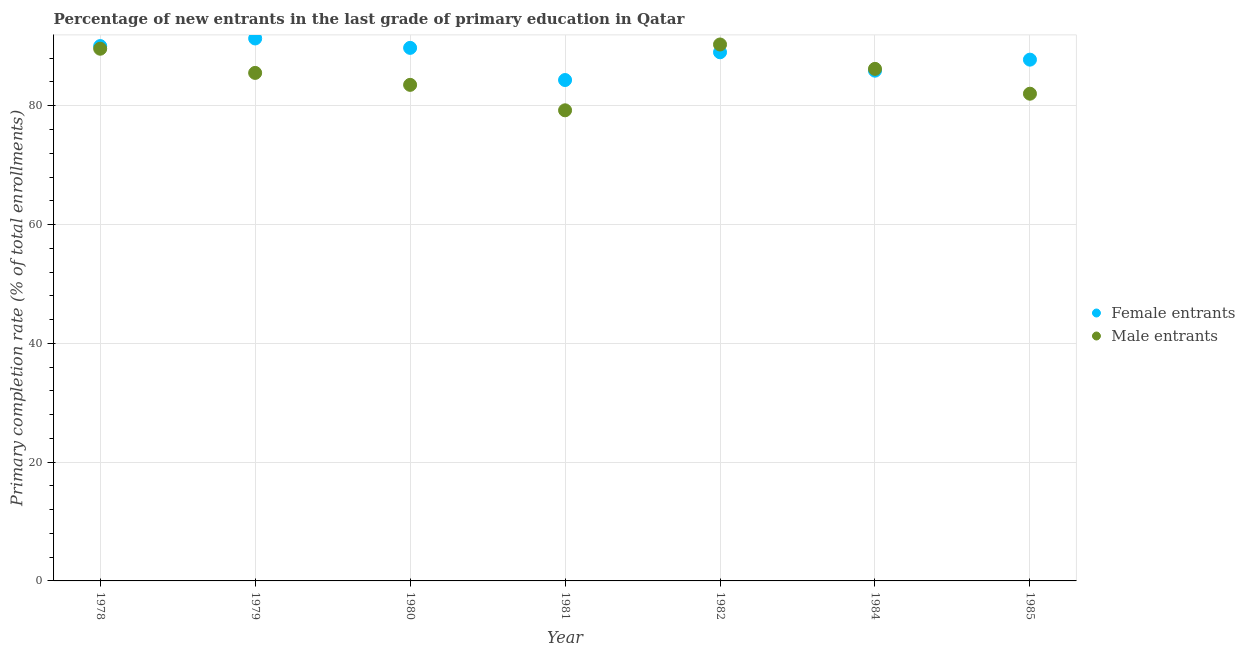How many different coloured dotlines are there?
Give a very brief answer. 2. Is the number of dotlines equal to the number of legend labels?
Offer a terse response. Yes. What is the primary completion rate of female entrants in 1982?
Make the answer very short. 89. Across all years, what is the maximum primary completion rate of male entrants?
Give a very brief answer. 90.31. Across all years, what is the minimum primary completion rate of male entrants?
Provide a succinct answer. 79.23. In which year was the primary completion rate of male entrants maximum?
Give a very brief answer. 1982. What is the total primary completion rate of male entrants in the graph?
Provide a short and direct response. 596.42. What is the difference between the primary completion rate of male entrants in 1978 and that in 1984?
Your answer should be very brief. 3.39. What is the difference between the primary completion rate of male entrants in 1982 and the primary completion rate of female entrants in 1979?
Give a very brief answer. -1.01. What is the average primary completion rate of female entrants per year?
Your answer should be very brief. 88.3. In the year 1980, what is the difference between the primary completion rate of male entrants and primary completion rate of female entrants?
Offer a terse response. -6.23. In how many years, is the primary completion rate of male entrants greater than 80 %?
Your answer should be very brief. 6. What is the ratio of the primary completion rate of male entrants in 1978 to that in 1984?
Your answer should be very brief. 1.04. Is the primary completion rate of male entrants in 1979 less than that in 1980?
Ensure brevity in your answer.  No. Is the difference between the primary completion rate of female entrants in 1981 and 1982 greater than the difference between the primary completion rate of male entrants in 1981 and 1982?
Provide a succinct answer. Yes. What is the difference between the highest and the second highest primary completion rate of female entrants?
Offer a terse response. 1.28. What is the difference between the highest and the lowest primary completion rate of male entrants?
Provide a succinct answer. 11.08. In how many years, is the primary completion rate of male entrants greater than the average primary completion rate of male entrants taken over all years?
Ensure brevity in your answer.  4. Is the sum of the primary completion rate of female entrants in 1979 and 1982 greater than the maximum primary completion rate of male entrants across all years?
Your response must be concise. Yes. Is the primary completion rate of female entrants strictly less than the primary completion rate of male entrants over the years?
Provide a succinct answer. No. How many years are there in the graph?
Make the answer very short. 7. What is the difference between two consecutive major ticks on the Y-axis?
Keep it short and to the point. 20. Are the values on the major ticks of Y-axis written in scientific E-notation?
Ensure brevity in your answer.  No. Does the graph contain any zero values?
Your answer should be very brief. No. Does the graph contain grids?
Your response must be concise. Yes. Where does the legend appear in the graph?
Give a very brief answer. Center right. What is the title of the graph?
Your answer should be very brief. Percentage of new entrants in the last grade of primary education in Qatar. What is the label or title of the Y-axis?
Make the answer very short. Primary completion rate (% of total enrollments). What is the Primary completion rate (% of total enrollments) in Female entrants in 1978?
Give a very brief answer. 90.05. What is the Primary completion rate (% of total enrollments) in Male entrants in 1978?
Offer a very short reply. 89.6. What is the Primary completion rate (% of total enrollments) of Female entrants in 1979?
Provide a succinct answer. 91.33. What is the Primary completion rate (% of total enrollments) of Male entrants in 1979?
Make the answer very short. 85.53. What is the Primary completion rate (% of total enrollments) of Female entrants in 1980?
Your answer should be compact. 89.74. What is the Primary completion rate (% of total enrollments) of Male entrants in 1980?
Keep it short and to the point. 83.52. What is the Primary completion rate (% of total enrollments) of Female entrants in 1981?
Provide a short and direct response. 84.33. What is the Primary completion rate (% of total enrollments) in Male entrants in 1981?
Make the answer very short. 79.23. What is the Primary completion rate (% of total enrollments) of Female entrants in 1982?
Offer a terse response. 89. What is the Primary completion rate (% of total enrollments) in Male entrants in 1982?
Provide a short and direct response. 90.31. What is the Primary completion rate (% of total enrollments) of Female entrants in 1984?
Provide a succinct answer. 85.9. What is the Primary completion rate (% of total enrollments) of Male entrants in 1984?
Offer a very short reply. 86.21. What is the Primary completion rate (% of total enrollments) in Female entrants in 1985?
Keep it short and to the point. 87.76. What is the Primary completion rate (% of total enrollments) in Male entrants in 1985?
Keep it short and to the point. 82.03. Across all years, what is the maximum Primary completion rate (% of total enrollments) in Female entrants?
Keep it short and to the point. 91.33. Across all years, what is the maximum Primary completion rate (% of total enrollments) in Male entrants?
Your answer should be compact. 90.31. Across all years, what is the minimum Primary completion rate (% of total enrollments) of Female entrants?
Make the answer very short. 84.33. Across all years, what is the minimum Primary completion rate (% of total enrollments) of Male entrants?
Provide a short and direct response. 79.23. What is the total Primary completion rate (% of total enrollments) of Female entrants in the graph?
Your answer should be very brief. 618.11. What is the total Primary completion rate (% of total enrollments) of Male entrants in the graph?
Give a very brief answer. 596.42. What is the difference between the Primary completion rate (% of total enrollments) of Female entrants in 1978 and that in 1979?
Your answer should be compact. -1.28. What is the difference between the Primary completion rate (% of total enrollments) of Male entrants in 1978 and that in 1979?
Ensure brevity in your answer.  4.07. What is the difference between the Primary completion rate (% of total enrollments) of Female entrants in 1978 and that in 1980?
Keep it short and to the point. 0.3. What is the difference between the Primary completion rate (% of total enrollments) in Male entrants in 1978 and that in 1980?
Give a very brief answer. 6.08. What is the difference between the Primary completion rate (% of total enrollments) of Female entrants in 1978 and that in 1981?
Your response must be concise. 5.72. What is the difference between the Primary completion rate (% of total enrollments) of Male entrants in 1978 and that in 1981?
Your response must be concise. 10.37. What is the difference between the Primary completion rate (% of total enrollments) of Female entrants in 1978 and that in 1982?
Make the answer very short. 1.04. What is the difference between the Primary completion rate (% of total enrollments) in Male entrants in 1978 and that in 1982?
Keep it short and to the point. -0.71. What is the difference between the Primary completion rate (% of total enrollments) in Female entrants in 1978 and that in 1984?
Ensure brevity in your answer.  4.14. What is the difference between the Primary completion rate (% of total enrollments) of Male entrants in 1978 and that in 1984?
Provide a succinct answer. 3.39. What is the difference between the Primary completion rate (% of total enrollments) of Female entrants in 1978 and that in 1985?
Give a very brief answer. 2.29. What is the difference between the Primary completion rate (% of total enrollments) of Male entrants in 1978 and that in 1985?
Your answer should be compact. 7.57. What is the difference between the Primary completion rate (% of total enrollments) in Female entrants in 1979 and that in 1980?
Provide a succinct answer. 1.58. What is the difference between the Primary completion rate (% of total enrollments) in Male entrants in 1979 and that in 1980?
Ensure brevity in your answer.  2.01. What is the difference between the Primary completion rate (% of total enrollments) of Female entrants in 1979 and that in 1981?
Your answer should be compact. 7. What is the difference between the Primary completion rate (% of total enrollments) of Male entrants in 1979 and that in 1981?
Offer a terse response. 6.3. What is the difference between the Primary completion rate (% of total enrollments) in Female entrants in 1979 and that in 1982?
Give a very brief answer. 2.32. What is the difference between the Primary completion rate (% of total enrollments) in Male entrants in 1979 and that in 1982?
Your answer should be very brief. -4.79. What is the difference between the Primary completion rate (% of total enrollments) in Female entrants in 1979 and that in 1984?
Provide a short and direct response. 5.42. What is the difference between the Primary completion rate (% of total enrollments) of Male entrants in 1979 and that in 1984?
Offer a terse response. -0.68. What is the difference between the Primary completion rate (% of total enrollments) in Female entrants in 1979 and that in 1985?
Give a very brief answer. 3.57. What is the difference between the Primary completion rate (% of total enrollments) of Male entrants in 1979 and that in 1985?
Make the answer very short. 3.5. What is the difference between the Primary completion rate (% of total enrollments) of Female entrants in 1980 and that in 1981?
Your answer should be compact. 5.41. What is the difference between the Primary completion rate (% of total enrollments) in Male entrants in 1980 and that in 1981?
Provide a succinct answer. 4.28. What is the difference between the Primary completion rate (% of total enrollments) in Female entrants in 1980 and that in 1982?
Your response must be concise. 0.74. What is the difference between the Primary completion rate (% of total enrollments) in Male entrants in 1980 and that in 1982?
Make the answer very short. -6.8. What is the difference between the Primary completion rate (% of total enrollments) of Female entrants in 1980 and that in 1984?
Your answer should be compact. 3.84. What is the difference between the Primary completion rate (% of total enrollments) in Male entrants in 1980 and that in 1984?
Provide a short and direct response. -2.69. What is the difference between the Primary completion rate (% of total enrollments) of Female entrants in 1980 and that in 1985?
Offer a very short reply. 1.98. What is the difference between the Primary completion rate (% of total enrollments) of Male entrants in 1980 and that in 1985?
Your response must be concise. 1.49. What is the difference between the Primary completion rate (% of total enrollments) in Female entrants in 1981 and that in 1982?
Make the answer very short. -4.67. What is the difference between the Primary completion rate (% of total enrollments) in Male entrants in 1981 and that in 1982?
Provide a succinct answer. -11.08. What is the difference between the Primary completion rate (% of total enrollments) in Female entrants in 1981 and that in 1984?
Your answer should be very brief. -1.57. What is the difference between the Primary completion rate (% of total enrollments) of Male entrants in 1981 and that in 1984?
Make the answer very short. -6.98. What is the difference between the Primary completion rate (% of total enrollments) of Female entrants in 1981 and that in 1985?
Make the answer very short. -3.43. What is the difference between the Primary completion rate (% of total enrollments) of Male entrants in 1981 and that in 1985?
Keep it short and to the point. -2.79. What is the difference between the Primary completion rate (% of total enrollments) in Female entrants in 1982 and that in 1984?
Keep it short and to the point. 3.1. What is the difference between the Primary completion rate (% of total enrollments) of Male entrants in 1982 and that in 1984?
Provide a short and direct response. 4.11. What is the difference between the Primary completion rate (% of total enrollments) of Female entrants in 1982 and that in 1985?
Give a very brief answer. 1.24. What is the difference between the Primary completion rate (% of total enrollments) in Male entrants in 1982 and that in 1985?
Provide a succinct answer. 8.29. What is the difference between the Primary completion rate (% of total enrollments) in Female entrants in 1984 and that in 1985?
Make the answer very short. -1.86. What is the difference between the Primary completion rate (% of total enrollments) of Male entrants in 1984 and that in 1985?
Provide a succinct answer. 4.18. What is the difference between the Primary completion rate (% of total enrollments) of Female entrants in 1978 and the Primary completion rate (% of total enrollments) of Male entrants in 1979?
Your response must be concise. 4.52. What is the difference between the Primary completion rate (% of total enrollments) in Female entrants in 1978 and the Primary completion rate (% of total enrollments) in Male entrants in 1980?
Your answer should be compact. 6.53. What is the difference between the Primary completion rate (% of total enrollments) in Female entrants in 1978 and the Primary completion rate (% of total enrollments) in Male entrants in 1981?
Ensure brevity in your answer.  10.81. What is the difference between the Primary completion rate (% of total enrollments) of Female entrants in 1978 and the Primary completion rate (% of total enrollments) of Male entrants in 1982?
Make the answer very short. -0.27. What is the difference between the Primary completion rate (% of total enrollments) in Female entrants in 1978 and the Primary completion rate (% of total enrollments) in Male entrants in 1984?
Make the answer very short. 3.84. What is the difference between the Primary completion rate (% of total enrollments) of Female entrants in 1978 and the Primary completion rate (% of total enrollments) of Male entrants in 1985?
Ensure brevity in your answer.  8.02. What is the difference between the Primary completion rate (% of total enrollments) in Female entrants in 1979 and the Primary completion rate (% of total enrollments) in Male entrants in 1980?
Make the answer very short. 7.81. What is the difference between the Primary completion rate (% of total enrollments) in Female entrants in 1979 and the Primary completion rate (% of total enrollments) in Male entrants in 1981?
Give a very brief answer. 12.09. What is the difference between the Primary completion rate (% of total enrollments) of Female entrants in 1979 and the Primary completion rate (% of total enrollments) of Male entrants in 1982?
Keep it short and to the point. 1.01. What is the difference between the Primary completion rate (% of total enrollments) of Female entrants in 1979 and the Primary completion rate (% of total enrollments) of Male entrants in 1984?
Offer a terse response. 5.12. What is the difference between the Primary completion rate (% of total enrollments) in Female entrants in 1979 and the Primary completion rate (% of total enrollments) in Male entrants in 1985?
Your answer should be very brief. 9.3. What is the difference between the Primary completion rate (% of total enrollments) of Female entrants in 1980 and the Primary completion rate (% of total enrollments) of Male entrants in 1981?
Give a very brief answer. 10.51. What is the difference between the Primary completion rate (% of total enrollments) of Female entrants in 1980 and the Primary completion rate (% of total enrollments) of Male entrants in 1982?
Your answer should be very brief. -0.57. What is the difference between the Primary completion rate (% of total enrollments) in Female entrants in 1980 and the Primary completion rate (% of total enrollments) in Male entrants in 1984?
Provide a succinct answer. 3.53. What is the difference between the Primary completion rate (% of total enrollments) of Female entrants in 1980 and the Primary completion rate (% of total enrollments) of Male entrants in 1985?
Your response must be concise. 7.72. What is the difference between the Primary completion rate (% of total enrollments) in Female entrants in 1981 and the Primary completion rate (% of total enrollments) in Male entrants in 1982?
Provide a short and direct response. -5.98. What is the difference between the Primary completion rate (% of total enrollments) of Female entrants in 1981 and the Primary completion rate (% of total enrollments) of Male entrants in 1984?
Your response must be concise. -1.88. What is the difference between the Primary completion rate (% of total enrollments) of Female entrants in 1981 and the Primary completion rate (% of total enrollments) of Male entrants in 1985?
Make the answer very short. 2.3. What is the difference between the Primary completion rate (% of total enrollments) of Female entrants in 1982 and the Primary completion rate (% of total enrollments) of Male entrants in 1984?
Keep it short and to the point. 2.79. What is the difference between the Primary completion rate (% of total enrollments) in Female entrants in 1982 and the Primary completion rate (% of total enrollments) in Male entrants in 1985?
Your answer should be very brief. 6.98. What is the difference between the Primary completion rate (% of total enrollments) in Female entrants in 1984 and the Primary completion rate (% of total enrollments) in Male entrants in 1985?
Ensure brevity in your answer.  3.88. What is the average Primary completion rate (% of total enrollments) of Female entrants per year?
Ensure brevity in your answer.  88.3. What is the average Primary completion rate (% of total enrollments) in Male entrants per year?
Make the answer very short. 85.2. In the year 1978, what is the difference between the Primary completion rate (% of total enrollments) in Female entrants and Primary completion rate (% of total enrollments) in Male entrants?
Offer a terse response. 0.45. In the year 1979, what is the difference between the Primary completion rate (% of total enrollments) in Female entrants and Primary completion rate (% of total enrollments) in Male entrants?
Offer a very short reply. 5.8. In the year 1980, what is the difference between the Primary completion rate (% of total enrollments) in Female entrants and Primary completion rate (% of total enrollments) in Male entrants?
Ensure brevity in your answer.  6.23. In the year 1981, what is the difference between the Primary completion rate (% of total enrollments) in Female entrants and Primary completion rate (% of total enrollments) in Male entrants?
Make the answer very short. 5.1. In the year 1982, what is the difference between the Primary completion rate (% of total enrollments) of Female entrants and Primary completion rate (% of total enrollments) of Male entrants?
Keep it short and to the point. -1.31. In the year 1984, what is the difference between the Primary completion rate (% of total enrollments) in Female entrants and Primary completion rate (% of total enrollments) in Male entrants?
Your response must be concise. -0.3. In the year 1985, what is the difference between the Primary completion rate (% of total enrollments) in Female entrants and Primary completion rate (% of total enrollments) in Male entrants?
Your response must be concise. 5.73. What is the ratio of the Primary completion rate (% of total enrollments) in Female entrants in 1978 to that in 1979?
Make the answer very short. 0.99. What is the ratio of the Primary completion rate (% of total enrollments) in Male entrants in 1978 to that in 1979?
Keep it short and to the point. 1.05. What is the ratio of the Primary completion rate (% of total enrollments) of Male entrants in 1978 to that in 1980?
Provide a short and direct response. 1.07. What is the ratio of the Primary completion rate (% of total enrollments) of Female entrants in 1978 to that in 1981?
Offer a very short reply. 1.07. What is the ratio of the Primary completion rate (% of total enrollments) of Male entrants in 1978 to that in 1981?
Your response must be concise. 1.13. What is the ratio of the Primary completion rate (% of total enrollments) in Female entrants in 1978 to that in 1982?
Offer a terse response. 1.01. What is the ratio of the Primary completion rate (% of total enrollments) of Female entrants in 1978 to that in 1984?
Ensure brevity in your answer.  1.05. What is the ratio of the Primary completion rate (% of total enrollments) of Male entrants in 1978 to that in 1984?
Your answer should be compact. 1.04. What is the ratio of the Primary completion rate (% of total enrollments) of Female entrants in 1978 to that in 1985?
Make the answer very short. 1.03. What is the ratio of the Primary completion rate (% of total enrollments) in Male entrants in 1978 to that in 1985?
Offer a very short reply. 1.09. What is the ratio of the Primary completion rate (% of total enrollments) in Female entrants in 1979 to that in 1980?
Offer a terse response. 1.02. What is the ratio of the Primary completion rate (% of total enrollments) in Male entrants in 1979 to that in 1980?
Ensure brevity in your answer.  1.02. What is the ratio of the Primary completion rate (% of total enrollments) in Female entrants in 1979 to that in 1981?
Keep it short and to the point. 1.08. What is the ratio of the Primary completion rate (% of total enrollments) in Male entrants in 1979 to that in 1981?
Provide a short and direct response. 1.08. What is the ratio of the Primary completion rate (% of total enrollments) in Female entrants in 1979 to that in 1982?
Offer a very short reply. 1.03. What is the ratio of the Primary completion rate (% of total enrollments) in Male entrants in 1979 to that in 1982?
Offer a terse response. 0.95. What is the ratio of the Primary completion rate (% of total enrollments) in Female entrants in 1979 to that in 1984?
Give a very brief answer. 1.06. What is the ratio of the Primary completion rate (% of total enrollments) in Female entrants in 1979 to that in 1985?
Keep it short and to the point. 1.04. What is the ratio of the Primary completion rate (% of total enrollments) of Male entrants in 1979 to that in 1985?
Your response must be concise. 1.04. What is the ratio of the Primary completion rate (% of total enrollments) in Female entrants in 1980 to that in 1981?
Keep it short and to the point. 1.06. What is the ratio of the Primary completion rate (% of total enrollments) in Male entrants in 1980 to that in 1981?
Your response must be concise. 1.05. What is the ratio of the Primary completion rate (% of total enrollments) of Female entrants in 1980 to that in 1982?
Provide a succinct answer. 1.01. What is the ratio of the Primary completion rate (% of total enrollments) of Male entrants in 1980 to that in 1982?
Your answer should be compact. 0.92. What is the ratio of the Primary completion rate (% of total enrollments) in Female entrants in 1980 to that in 1984?
Your response must be concise. 1.04. What is the ratio of the Primary completion rate (% of total enrollments) of Male entrants in 1980 to that in 1984?
Give a very brief answer. 0.97. What is the ratio of the Primary completion rate (% of total enrollments) in Female entrants in 1980 to that in 1985?
Your response must be concise. 1.02. What is the ratio of the Primary completion rate (% of total enrollments) in Male entrants in 1980 to that in 1985?
Provide a short and direct response. 1.02. What is the ratio of the Primary completion rate (% of total enrollments) in Female entrants in 1981 to that in 1982?
Offer a terse response. 0.95. What is the ratio of the Primary completion rate (% of total enrollments) in Male entrants in 1981 to that in 1982?
Your answer should be very brief. 0.88. What is the ratio of the Primary completion rate (% of total enrollments) of Female entrants in 1981 to that in 1984?
Provide a succinct answer. 0.98. What is the ratio of the Primary completion rate (% of total enrollments) in Male entrants in 1981 to that in 1984?
Ensure brevity in your answer.  0.92. What is the ratio of the Primary completion rate (% of total enrollments) of Female entrants in 1981 to that in 1985?
Provide a succinct answer. 0.96. What is the ratio of the Primary completion rate (% of total enrollments) of Male entrants in 1981 to that in 1985?
Offer a terse response. 0.97. What is the ratio of the Primary completion rate (% of total enrollments) of Female entrants in 1982 to that in 1984?
Offer a very short reply. 1.04. What is the ratio of the Primary completion rate (% of total enrollments) of Male entrants in 1982 to that in 1984?
Your answer should be compact. 1.05. What is the ratio of the Primary completion rate (% of total enrollments) in Female entrants in 1982 to that in 1985?
Offer a terse response. 1.01. What is the ratio of the Primary completion rate (% of total enrollments) in Male entrants in 1982 to that in 1985?
Make the answer very short. 1.1. What is the ratio of the Primary completion rate (% of total enrollments) of Female entrants in 1984 to that in 1985?
Ensure brevity in your answer.  0.98. What is the ratio of the Primary completion rate (% of total enrollments) in Male entrants in 1984 to that in 1985?
Your answer should be very brief. 1.05. What is the difference between the highest and the second highest Primary completion rate (% of total enrollments) of Female entrants?
Keep it short and to the point. 1.28. What is the difference between the highest and the second highest Primary completion rate (% of total enrollments) of Male entrants?
Ensure brevity in your answer.  0.71. What is the difference between the highest and the lowest Primary completion rate (% of total enrollments) of Female entrants?
Give a very brief answer. 7. What is the difference between the highest and the lowest Primary completion rate (% of total enrollments) in Male entrants?
Make the answer very short. 11.08. 